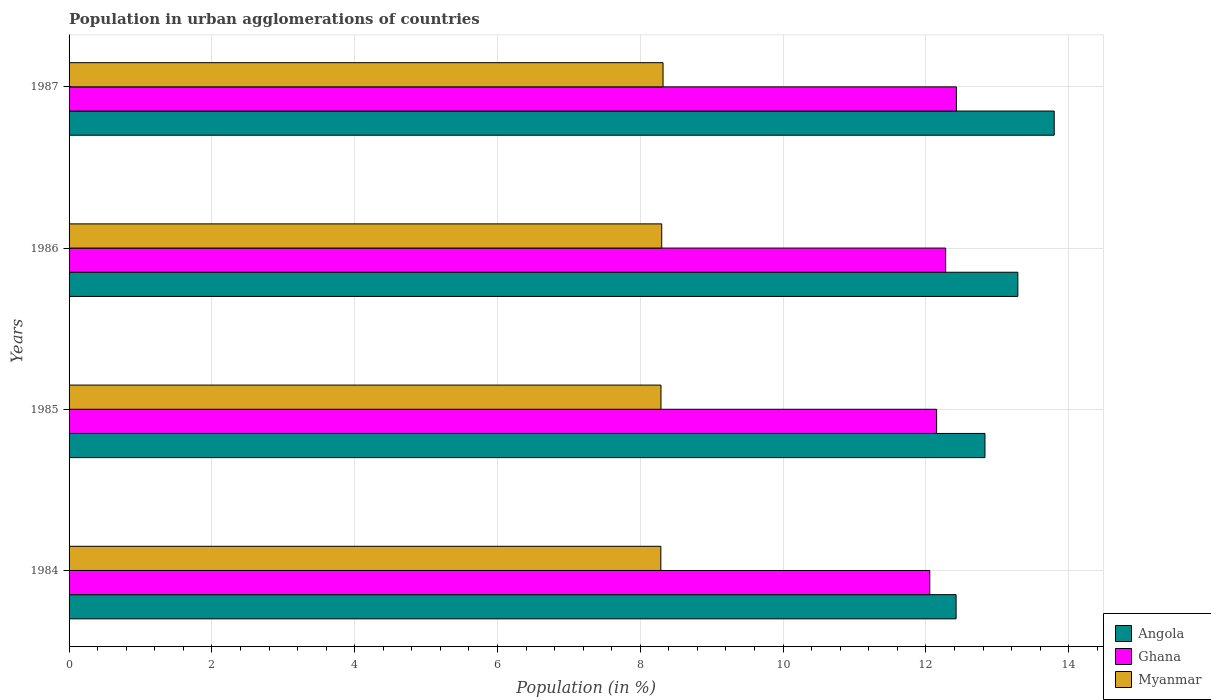How many groups of bars are there?
Ensure brevity in your answer.  4. How many bars are there on the 3rd tick from the top?
Your answer should be compact. 3. In how many cases, is the number of bars for a given year not equal to the number of legend labels?
Provide a short and direct response. 0. What is the percentage of population in urban agglomerations in Myanmar in 1985?
Your response must be concise. 8.29. Across all years, what is the maximum percentage of population in urban agglomerations in Angola?
Keep it short and to the point. 13.8. Across all years, what is the minimum percentage of population in urban agglomerations in Myanmar?
Provide a succinct answer. 8.29. In which year was the percentage of population in urban agglomerations in Ghana maximum?
Make the answer very short. 1987. What is the total percentage of population in urban agglomerations in Ghana in the graph?
Give a very brief answer. 48.91. What is the difference between the percentage of population in urban agglomerations in Ghana in 1984 and that in 1986?
Provide a short and direct response. -0.22. What is the difference between the percentage of population in urban agglomerations in Ghana in 1987 and the percentage of population in urban agglomerations in Myanmar in 1985?
Offer a very short reply. 4.14. What is the average percentage of population in urban agglomerations in Angola per year?
Provide a short and direct response. 13.08. In the year 1985, what is the difference between the percentage of population in urban agglomerations in Angola and percentage of population in urban agglomerations in Myanmar?
Keep it short and to the point. 4.54. In how many years, is the percentage of population in urban agglomerations in Myanmar greater than 10.8 %?
Provide a short and direct response. 0. What is the ratio of the percentage of population in urban agglomerations in Angola in 1984 to that in 1986?
Your answer should be compact. 0.93. Is the percentage of population in urban agglomerations in Angola in 1984 less than that in 1986?
Your answer should be compact. Yes. Is the difference between the percentage of population in urban agglomerations in Angola in 1986 and 1987 greater than the difference between the percentage of population in urban agglomerations in Myanmar in 1986 and 1987?
Provide a succinct answer. No. What is the difference between the highest and the second highest percentage of population in urban agglomerations in Angola?
Provide a succinct answer. 0.51. What is the difference between the highest and the lowest percentage of population in urban agglomerations in Ghana?
Give a very brief answer. 0.37. What does the 2nd bar from the top in 1984 represents?
Provide a succinct answer. Ghana. What does the 3rd bar from the bottom in 1986 represents?
Keep it short and to the point. Myanmar. How many bars are there?
Offer a very short reply. 12. Are all the bars in the graph horizontal?
Keep it short and to the point. Yes. Does the graph contain any zero values?
Provide a short and direct response. No. Does the graph contain grids?
Offer a terse response. Yes. What is the title of the graph?
Your answer should be very brief. Population in urban agglomerations of countries. Does "Bosnia and Herzegovina" appear as one of the legend labels in the graph?
Give a very brief answer. No. What is the label or title of the X-axis?
Ensure brevity in your answer.  Population (in %). What is the Population (in %) in Angola in 1984?
Your response must be concise. 12.42. What is the Population (in %) of Ghana in 1984?
Offer a terse response. 12.05. What is the Population (in %) of Myanmar in 1984?
Give a very brief answer. 8.29. What is the Population (in %) in Angola in 1985?
Keep it short and to the point. 12.83. What is the Population (in %) of Ghana in 1985?
Keep it short and to the point. 12.15. What is the Population (in %) in Myanmar in 1985?
Keep it short and to the point. 8.29. What is the Population (in %) of Angola in 1986?
Make the answer very short. 13.29. What is the Population (in %) in Ghana in 1986?
Keep it short and to the point. 12.28. What is the Population (in %) of Myanmar in 1986?
Offer a very short reply. 8.3. What is the Population (in %) in Angola in 1987?
Your answer should be very brief. 13.8. What is the Population (in %) of Ghana in 1987?
Keep it short and to the point. 12.43. What is the Population (in %) in Myanmar in 1987?
Give a very brief answer. 8.32. Across all years, what is the maximum Population (in %) of Angola?
Your answer should be very brief. 13.8. Across all years, what is the maximum Population (in %) of Ghana?
Give a very brief answer. 12.43. Across all years, what is the maximum Population (in %) in Myanmar?
Ensure brevity in your answer.  8.32. Across all years, what is the minimum Population (in %) in Angola?
Make the answer very short. 12.42. Across all years, what is the minimum Population (in %) in Ghana?
Offer a terse response. 12.05. Across all years, what is the minimum Population (in %) in Myanmar?
Offer a terse response. 8.29. What is the total Population (in %) in Angola in the graph?
Ensure brevity in your answer.  52.33. What is the total Population (in %) of Ghana in the graph?
Offer a very short reply. 48.91. What is the total Population (in %) of Myanmar in the graph?
Offer a terse response. 33.2. What is the difference between the Population (in %) in Angola in 1984 and that in 1985?
Make the answer very short. -0.4. What is the difference between the Population (in %) in Ghana in 1984 and that in 1985?
Give a very brief answer. -0.1. What is the difference between the Population (in %) of Myanmar in 1984 and that in 1985?
Keep it short and to the point. -0. What is the difference between the Population (in %) in Angola in 1984 and that in 1986?
Make the answer very short. -0.86. What is the difference between the Population (in %) of Ghana in 1984 and that in 1986?
Your answer should be very brief. -0.22. What is the difference between the Population (in %) of Myanmar in 1984 and that in 1986?
Your response must be concise. -0.01. What is the difference between the Population (in %) in Angola in 1984 and that in 1987?
Give a very brief answer. -1.37. What is the difference between the Population (in %) of Ghana in 1984 and that in 1987?
Offer a very short reply. -0.37. What is the difference between the Population (in %) of Myanmar in 1984 and that in 1987?
Provide a succinct answer. -0.03. What is the difference between the Population (in %) in Angola in 1985 and that in 1986?
Ensure brevity in your answer.  -0.46. What is the difference between the Population (in %) of Ghana in 1985 and that in 1986?
Provide a succinct answer. -0.13. What is the difference between the Population (in %) in Myanmar in 1985 and that in 1986?
Provide a short and direct response. -0.01. What is the difference between the Population (in %) of Angola in 1985 and that in 1987?
Your response must be concise. -0.97. What is the difference between the Population (in %) of Ghana in 1985 and that in 1987?
Give a very brief answer. -0.28. What is the difference between the Population (in %) in Myanmar in 1985 and that in 1987?
Provide a succinct answer. -0.03. What is the difference between the Population (in %) in Angola in 1986 and that in 1987?
Provide a short and direct response. -0.51. What is the difference between the Population (in %) in Ghana in 1986 and that in 1987?
Your response must be concise. -0.15. What is the difference between the Population (in %) in Myanmar in 1986 and that in 1987?
Offer a very short reply. -0.02. What is the difference between the Population (in %) in Angola in 1984 and the Population (in %) in Ghana in 1985?
Give a very brief answer. 0.27. What is the difference between the Population (in %) of Angola in 1984 and the Population (in %) of Myanmar in 1985?
Your answer should be compact. 4.13. What is the difference between the Population (in %) of Ghana in 1984 and the Population (in %) of Myanmar in 1985?
Give a very brief answer. 3.76. What is the difference between the Population (in %) of Angola in 1984 and the Population (in %) of Ghana in 1986?
Ensure brevity in your answer.  0.15. What is the difference between the Population (in %) of Angola in 1984 and the Population (in %) of Myanmar in 1986?
Offer a terse response. 4.12. What is the difference between the Population (in %) in Ghana in 1984 and the Population (in %) in Myanmar in 1986?
Ensure brevity in your answer.  3.75. What is the difference between the Population (in %) in Angola in 1984 and the Population (in %) in Ghana in 1987?
Offer a terse response. -0. What is the difference between the Population (in %) of Angola in 1984 and the Population (in %) of Myanmar in 1987?
Make the answer very short. 4.1. What is the difference between the Population (in %) in Ghana in 1984 and the Population (in %) in Myanmar in 1987?
Ensure brevity in your answer.  3.74. What is the difference between the Population (in %) in Angola in 1985 and the Population (in %) in Ghana in 1986?
Give a very brief answer. 0.55. What is the difference between the Population (in %) of Angola in 1985 and the Population (in %) of Myanmar in 1986?
Your response must be concise. 4.53. What is the difference between the Population (in %) in Ghana in 1985 and the Population (in %) in Myanmar in 1986?
Your answer should be very brief. 3.85. What is the difference between the Population (in %) of Angola in 1985 and the Population (in %) of Ghana in 1987?
Offer a very short reply. 0.4. What is the difference between the Population (in %) of Angola in 1985 and the Population (in %) of Myanmar in 1987?
Offer a very short reply. 4.51. What is the difference between the Population (in %) in Ghana in 1985 and the Population (in %) in Myanmar in 1987?
Your answer should be very brief. 3.83. What is the difference between the Population (in %) of Angola in 1986 and the Population (in %) of Ghana in 1987?
Give a very brief answer. 0.86. What is the difference between the Population (in %) of Angola in 1986 and the Population (in %) of Myanmar in 1987?
Ensure brevity in your answer.  4.97. What is the difference between the Population (in %) of Ghana in 1986 and the Population (in %) of Myanmar in 1987?
Keep it short and to the point. 3.96. What is the average Population (in %) in Angola per year?
Your response must be concise. 13.08. What is the average Population (in %) of Ghana per year?
Offer a terse response. 12.23. What is the average Population (in %) of Myanmar per year?
Keep it short and to the point. 8.3. In the year 1984, what is the difference between the Population (in %) in Angola and Population (in %) in Ghana?
Keep it short and to the point. 0.37. In the year 1984, what is the difference between the Population (in %) of Angola and Population (in %) of Myanmar?
Offer a very short reply. 4.13. In the year 1984, what is the difference between the Population (in %) of Ghana and Population (in %) of Myanmar?
Provide a succinct answer. 3.77. In the year 1985, what is the difference between the Population (in %) of Angola and Population (in %) of Ghana?
Your answer should be compact. 0.68. In the year 1985, what is the difference between the Population (in %) in Angola and Population (in %) in Myanmar?
Your response must be concise. 4.54. In the year 1985, what is the difference between the Population (in %) of Ghana and Population (in %) of Myanmar?
Provide a succinct answer. 3.86. In the year 1986, what is the difference between the Population (in %) of Angola and Population (in %) of Ghana?
Provide a short and direct response. 1.01. In the year 1986, what is the difference between the Population (in %) in Angola and Population (in %) in Myanmar?
Offer a terse response. 4.99. In the year 1986, what is the difference between the Population (in %) in Ghana and Population (in %) in Myanmar?
Ensure brevity in your answer.  3.98. In the year 1987, what is the difference between the Population (in %) in Angola and Population (in %) in Ghana?
Provide a short and direct response. 1.37. In the year 1987, what is the difference between the Population (in %) in Angola and Population (in %) in Myanmar?
Your response must be concise. 5.48. In the year 1987, what is the difference between the Population (in %) in Ghana and Population (in %) in Myanmar?
Your answer should be very brief. 4.11. What is the ratio of the Population (in %) in Angola in 1984 to that in 1985?
Keep it short and to the point. 0.97. What is the ratio of the Population (in %) in Ghana in 1984 to that in 1985?
Your answer should be compact. 0.99. What is the ratio of the Population (in %) of Angola in 1984 to that in 1986?
Offer a terse response. 0.93. What is the ratio of the Population (in %) of Ghana in 1984 to that in 1986?
Your answer should be very brief. 0.98. What is the ratio of the Population (in %) in Myanmar in 1984 to that in 1986?
Your answer should be very brief. 1. What is the ratio of the Population (in %) in Angola in 1984 to that in 1987?
Make the answer very short. 0.9. What is the ratio of the Population (in %) in Myanmar in 1984 to that in 1987?
Ensure brevity in your answer.  1. What is the ratio of the Population (in %) in Angola in 1985 to that in 1986?
Make the answer very short. 0.97. What is the ratio of the Population (in %) of Myanmar in 1985 to that in 1986?
Your answer should be compact. 1. What is the ratio of the Population (in %) of Angola in 1985 to that in 1987?
Provide a short and direct response. 0.93. What is the ratio of the Population (in %) in Ghana in 1985 to that in 1987?
Provide a short and direct response. 0.98. What is the ratio of the Population (in %) in Angola in 1986 to that in 1987?
Ensure brevity in your answer.  0.96. What is the ratio of the Population (in %) in Ghana in 1986 to that in 1987?
Give a very brief answer. 0.99. What is the difference between the highest and the second highest Population (in %) of Angola?
Offer a very short reply. 0.51. What is the difference between the highest and the second highest Population (in %) of Ghana?
Give a very brief answer. 0.15. What is the difference between the highest and the second highest Population (in %) of Myanmar?
Keep it short and to the point. 0.02. What is the difference between the highest and the lowest Population (in %) of Angola?
Keep it short and to the point. 1.37. What is the difference between the highest and the lowest Population (in %) in Ghana?
Offer a terse response. 0.37. What is the difference between the highest and the lowest Population (in %) of Myanmar?
Your response must be concise. 0.03. 